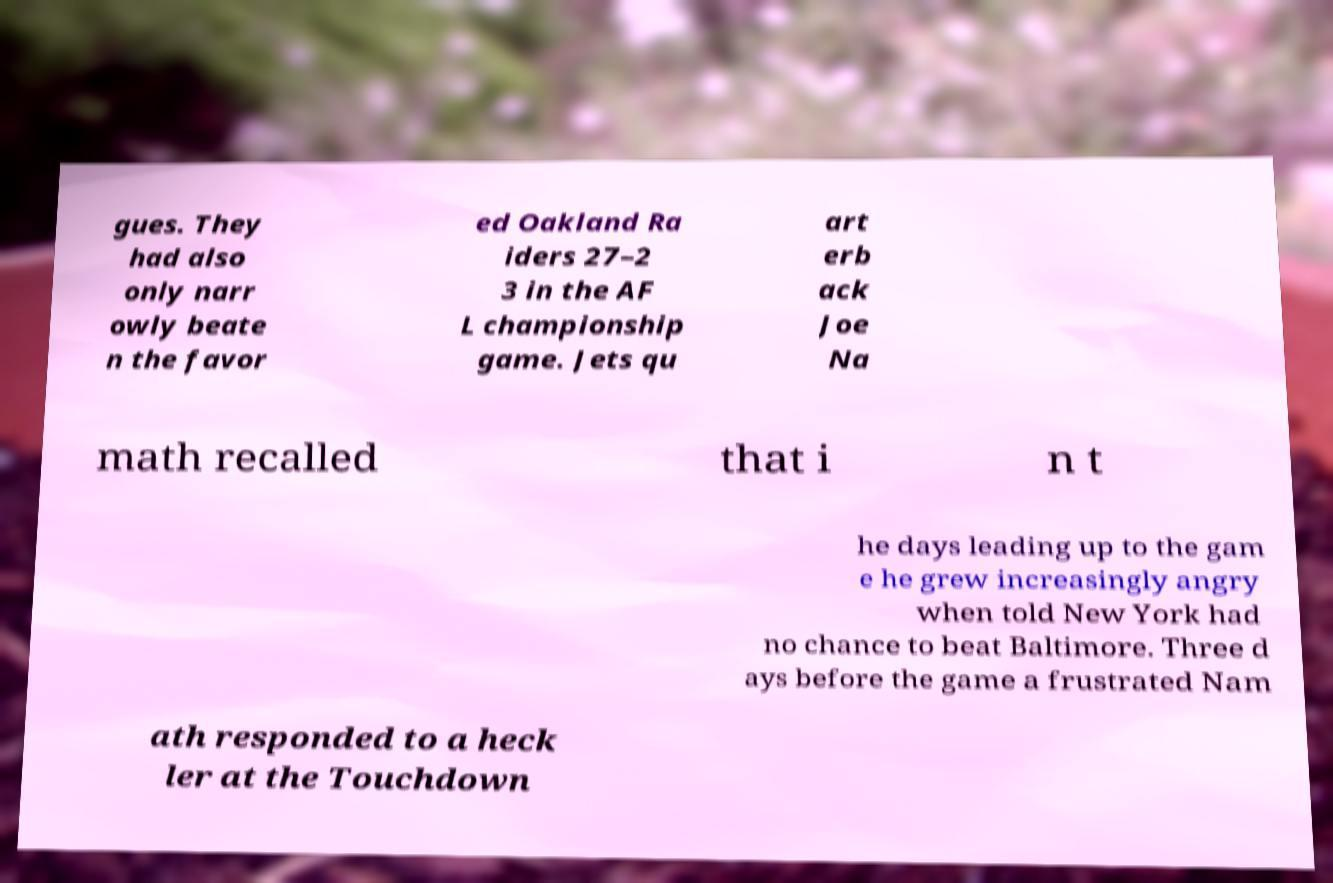Can you read and provide the text displayed in the image?This photo seems to have some interesting text. Can you extract and type it out for me? gues. They had also only narr owly beate n the favor ed Oakland Ra iders 27–2 3 in the AF L championship game. Jets qu art erb ack Joe Na math recalled that i n t he days leading up to the gam e he grew increasingly angry when told New York had no chance to beat Baltimore. Three d ays before the game a frustrated Nam ath responded to a heck ler at the Touchdown 